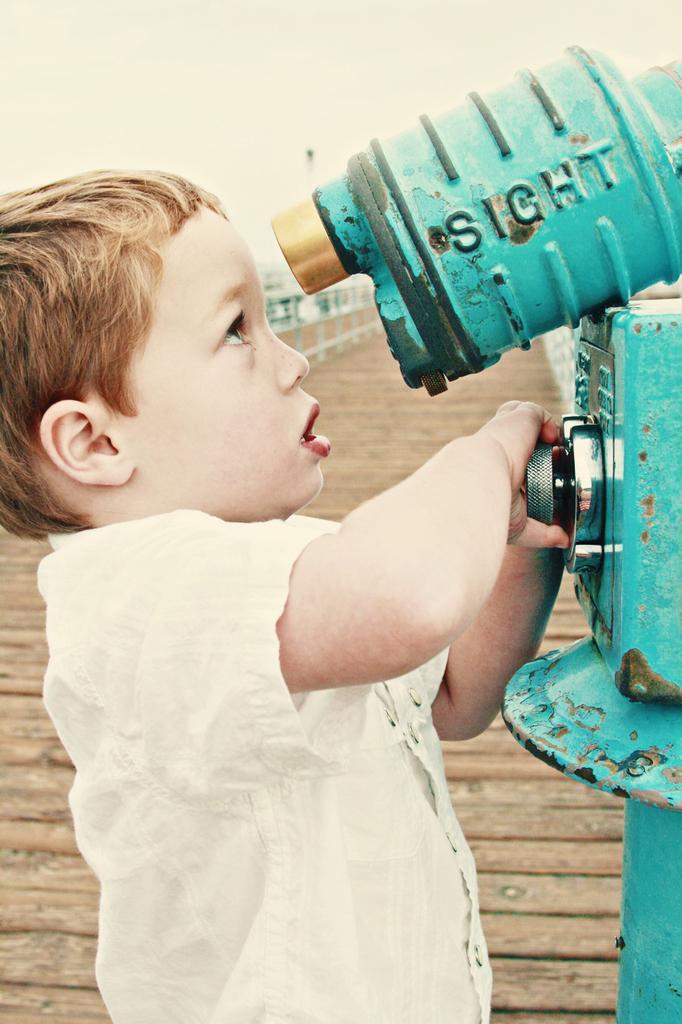Please provide a concise description of this image. In this picture I can observe a small boy wearing white color shirt. He is peeking through this blue color equipment. I can observe some text on this equipment. In the background there is a path. 